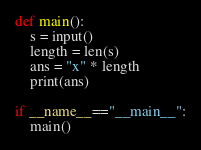<code> <loc_0><loc_0><loc_500><loc_500><_Python_>def main():
    s = input()
    length = len(s)
    ans = "x" * length
    print(ans)

if __name__=="__main__":
    main()</code> 